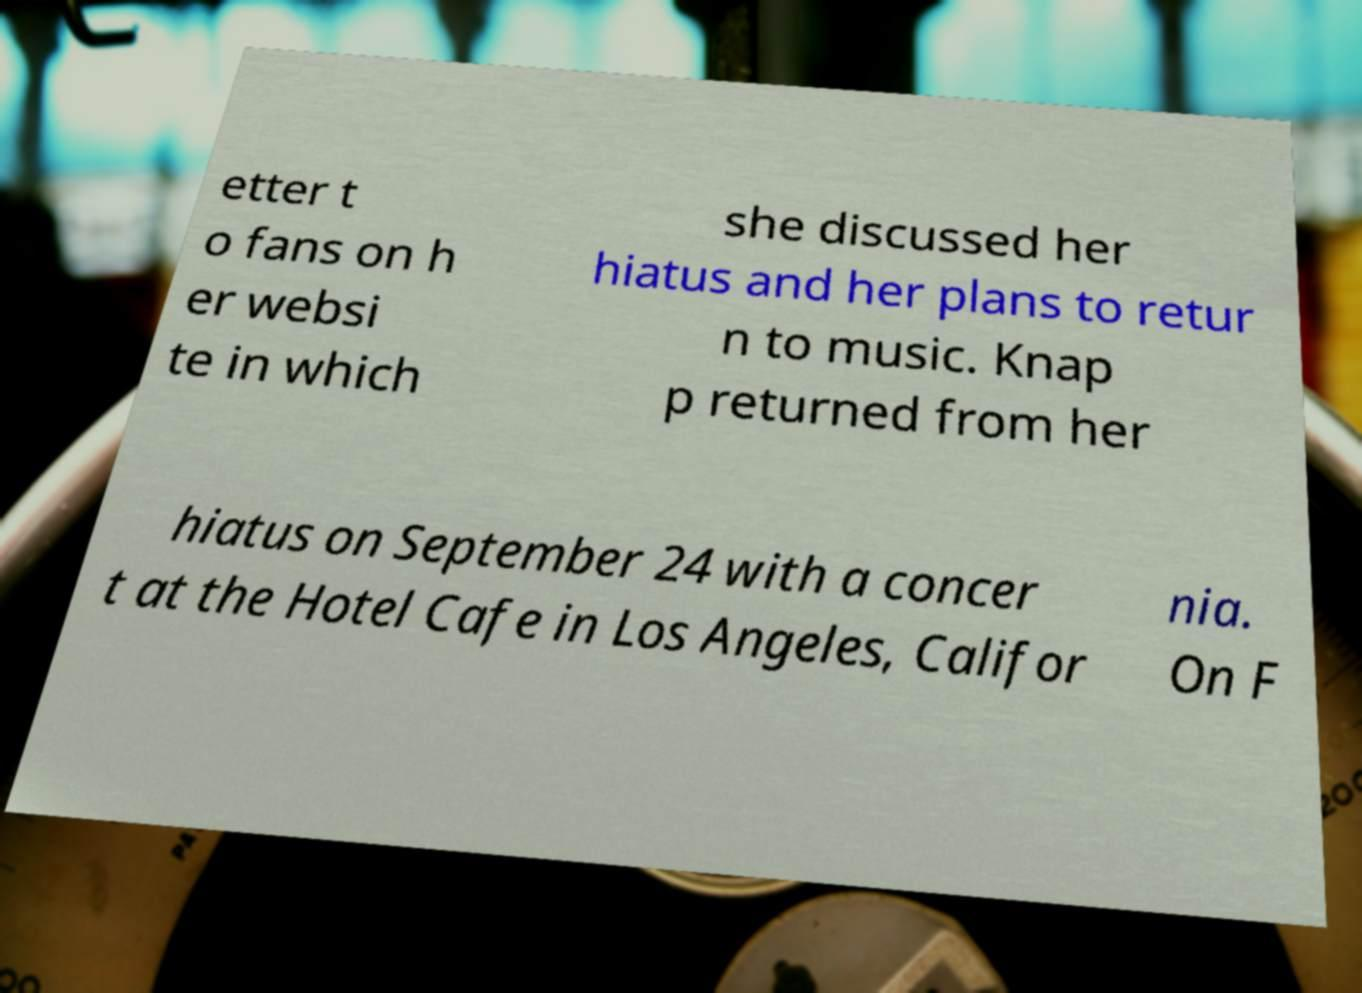I need the written content from this picture converted into text. Can you do that? etter t o fans on h er websi te in which she discussed her hiatus and her plans to retur n to music. Knap p returned from her hiatus on September 24 with a concer t at the Hotel Cafe in Los Angeles, Califor nia. On F 